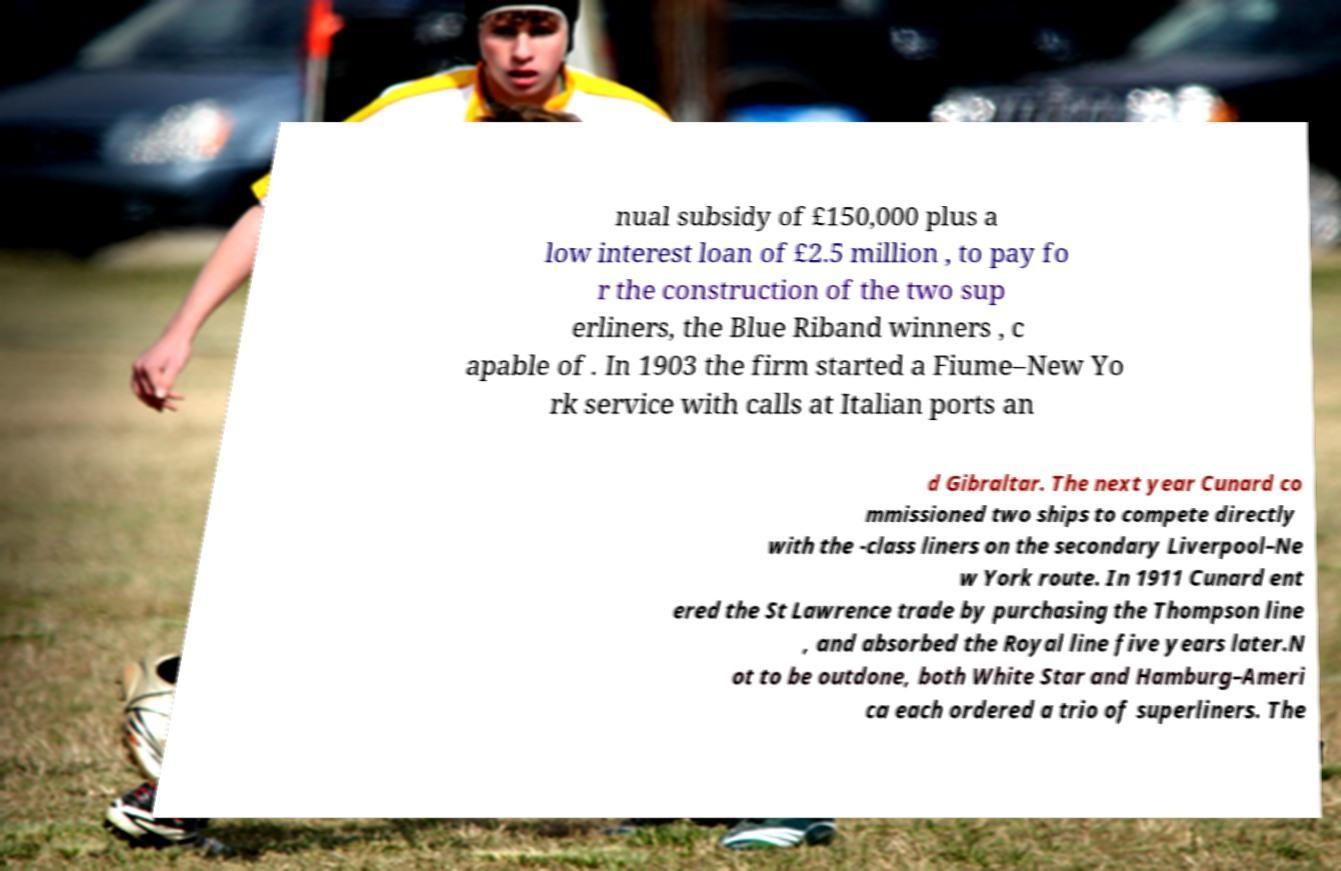Could you extract and type out the text from this image? nual subsidy of £150,000 plus a low interest loan of £2.5 million , to pay fo r the construction of the two sup erliners, the Blue Riband winners , c apable of . In 1903 the firm started a Fiume–New Yo rk service with calls at Italian ports an d Gibraltar. The next year Cunard co mmissioned two ships to compete directly with the -class liners on the secondary Liverpool–Ne w York route. In 1911 Cunard ent ered the St Lawrence trade by purchasing the Thompson line , and absorbed the Royal line five years later.N ot to be outdone, both White Star and Hamburg–Ameri ca each ordered a trio of superliners. The 